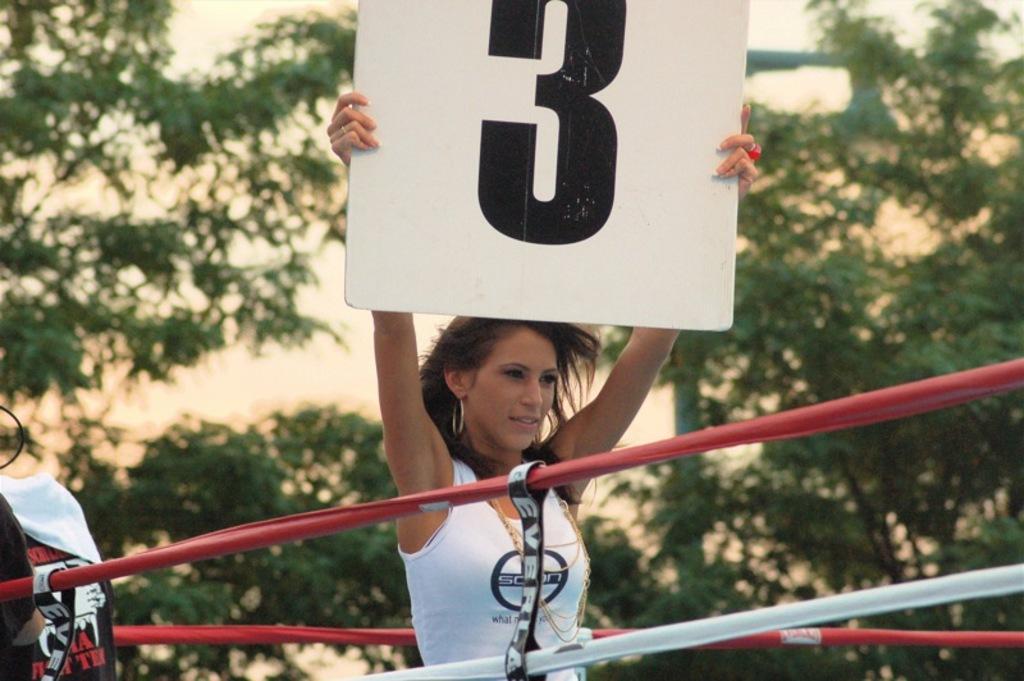Please provide a concise description of this image. In this image, we can see a woman is holding a play card and smiling. Here we can see ropes. On the left side of the image, we can see a banner and cloth. Background there is a blur view. Here we can see trees and poles. 